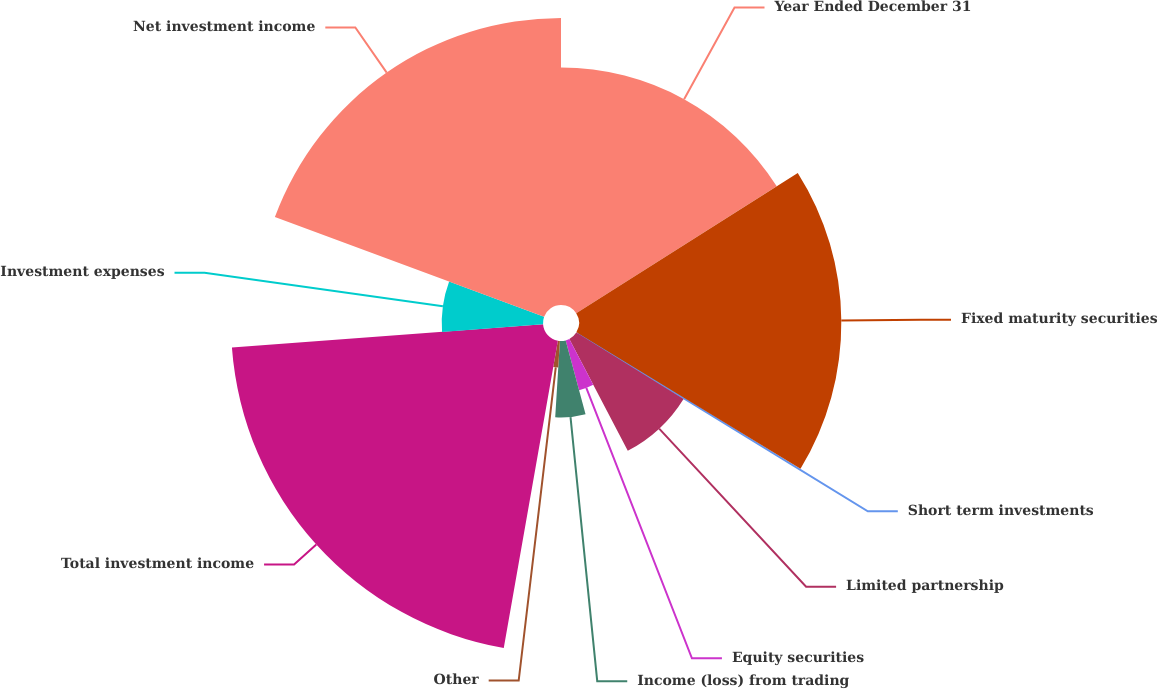<chart> <loc_0><loc_0><loc_500><loc_500><pie_chart><fcel>Year Ended December 31<fcel>Fixed maturity securities<fcel>Short term investments<fcel>Limited partnership<fcel>Equity securities<fcel>Income (loss) from trading<fcel>Other<fcel>Total investment income<fcel>Investment expenses<fcel>Net investment income<nl><fcel>16.01%<fcel>17.69%<fcel>0.13%<fcel>8.51%<fcel>3.48%<fcel>5.16%<fcel>1.8%<fcel>21.04%<fcel>6.83%<fcel>19.36%<nl></chart> 